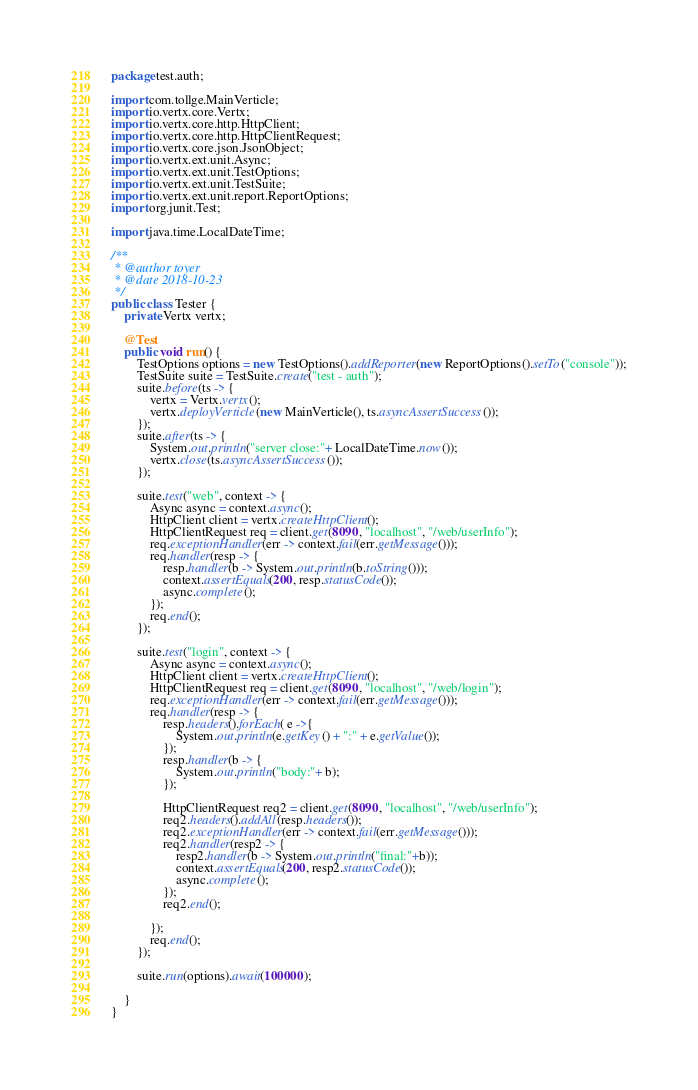Convert code to text. <code><loc_0><loc_0><loc_500><loc_500><_Java_>package test.auth;

import com.tollge.MainVerticle;
import io.vertx.core.Vertx;
import io.vertx.core.http.HttpClient;
import io.vertx.core.http.HttpClientRequest;
import io.vertx.core.json.JsonObject;
import io.vertx.ext.unit.Async;
import io.vertx.ext.unit.TestOptions;
import io.vertx.ext.unit.TestSuite;
import io.vertx.ext.unit.report.ReportOptions;
import org.junit.Test;

import java.time.LocalDateTime;

/**
 * @author toyer
 * @date 2018-10-23
 */
public class Tester {
    private Vertx vertx;

    @Test
    public void run() {
        TestOptions options = new TestOptions().addReporter(new ReportOptions().setTo("console"));
        TestSuite suite = TestSuite.create("test - auth");
        suite.before(ts -> {
            vertx = Vertx.vertx();
            vertx.deployVerticle(new MainVerticle(), ts.asyncAssertSuccess());
        });
        suite.after(ts -> {
            System.out.println("server close:"+ LocalDateTime.now());
            vertx.close(ts.asyncAssertSuccess());
        });

        suite.test("web", context -> {
            Async async = context.async();
            HttpClient client = vertx.createHttpClient();
            HttpClientRequest req = client.get(8090, "localhost", "/web/userInfo");
            req.exceptionHandler(err -> context.fail(err.getMessage()));
            req.handler(resp -> {
                resp.handler(b -> System.out.println(b.toString()));
                context.assertEquals(200, resp.statusCode());
                async.complete();
            });
            req.end();
        });

        suite.test("login", context -> {
            Async async = context.async();
            HttpClient client = vertx.createHttpClient();
            HttpClientRequest req = client.get(8090, "localhost", "/web/login");
            req.exceptionHandler(err -> context.fail(err.getMessage()));
            req.handler(resp -> {
                resp.headers().forEach( e ->{
                    System.out.println(e.getKey() + ":" + e.getValue());
                });
                resp.handler(b -> {
                    System.out.println("body:"+ b);
                });

                HttpClientRequest req2 = client.get(8090, "localhost", "/web/userInfo");
                req2.headers().addAll(resp.headers());
                req2.exceptionHandler(err -> context.fail(err.getMessage()));
                req2.handler(resp2 -> {
                    resp2.handler(b -> System.out.println("final:"+b));
                    context.assertEquals(200, resp2.statusCode());
                    async.complete();
                });
                req2.end();

            });
            req.end();
        });

        suite.run(options).await(100000);

    }
}
</code> 